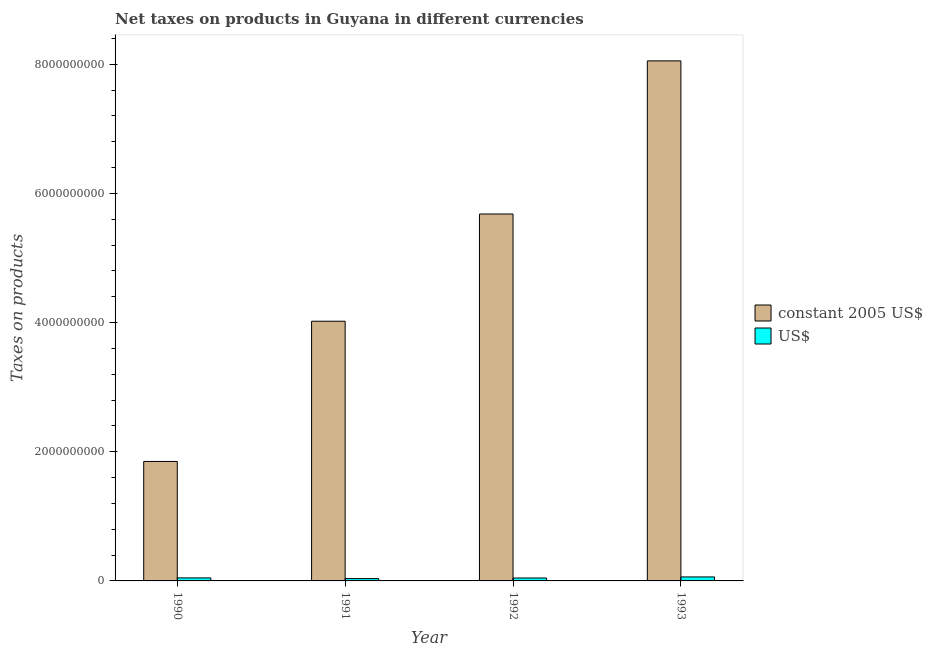How many groups of bars are there?
Your answer should be very brief. 4. Are the number of bars per tick equal to the number of legend labels?
Give a very brief answer. Yes. Are the number of bars on each tick of the X-axis equal?
Ensure brevity in your answer.  Yes. How many bars are there on the 1st tick from the left?
Your answer should be compact. 2. How many bars are there on the 4th tick from the right?
Provide a short and direct response. 2. What is the label of the 2nd group of bars from the left?
Keep it short and to the point. 1991. In how many cases, is the number of bars for a given year not equal to the number of legend labels?
Provide a succinct answer. 0. What is the net taxes in us$ in 1993?
Your answer should be compact. 6.18e+07. Across all years, what is the maximum net taxes in constant 2005 us$?
Your answer should be compact. 8.05e+09. Across all years, what is the minimum net taxes in constant 2005 us$?
Your answer should be very brief. 1.85e+09. In which year was the net taxes in constant 2005 us$ maximum?
Ensure brevity in your answer.  1993. In which year was the net taxes in us$ minimum?
Provide a short and direct response. 1991. What is the total net taxes in constant 2005 us$ in the graph?
Your answer should be compact. 1.96e+1. What is the difference between the net taxes in us$ in 1992 and that in 1993?
Your answer should be compact. -1.64e+07. What is the difference between the net taxes in us$ in 1991 and the net taxes in constant 2005 us$ in 1992?
Provide a succinct answer. -9.45e+06. What is the average net taxes in us$ per year?
Ensure brevity in your answer.  4.75e+07. In how many years, is the net taxes in constant 2005 us$ greater than 5600000000 units?
Your answer should be very brief. 2. What is the ratio of the net taxes in us$ in 1990 to that in 1992?
Offer a very short reply. 1.03. Is the net taxes in us$ in 1992 less than that in 1993?
Your response must be concise. Yes. What is the difference between the highest and the second highest net taxes in us$?
Provide a short and direct response. 1.50e+07. What is the difference between the highest and the lowest net taxes in constant 2005 us$?
Provide a short and direct response. 6.20e+09. In how many years, is the net taxes in constant 2005 us$ greater than the average net taxes in constant 2005 us$ taken over all years?
Ensure brevity in your answer.  2. What does the 1st bar from the left in 1990 represents?
Provide a succinct answer. Constant 2005 us$. What does the 2nd bar from the right in 1991 represents?
Keep it short and to the point. Constant 2005 us$. Are all the bars in the graph horizontal?
Make the answer very short. No. How many years are there in the graph?
Provide a short and direct response. 4. Does the graph contain any zero values?
Keep it short and to the point. No. Does the graph contain grids?
Your answer should be very brief. No. Where does the legend appear in the graph?
Provide a short and direct response. Center right. How many legend labels are there?
Give a very brief answer. 2. What is the title of the graph?
Provide a short and direct response. Net taxes on products in Guyana in different currencies. What is the label or title of the Y-axis?
Keep it short and to the point. Taxes on products. What is the Taxes on products in constant 2005 US$ in 1990?
Your answer should be compact. 1.85e+09. What is the Taxes on products in US$ in 1990?
Your answer should be very brief. 4.68e+07. What is the Taxes on products in constant 2005 US$ in 1991?
Offer a very short reply. 4.02e+09. What is the Taxes on products of US$ in 1991?
Ensure brevity in your answer.  3.60e+07. What is the Taxes on products in constant 2005 US$ in 1992?
Ensure brevity in your answer.  5.68e+09. What is the Taxes on products of US$ in 1992?
Provide a short and direct response. 4.54e+07. What is the Taxes on products of constant 2005 US$ in 1993?
Offer a terse response. 8.05e+09. What is the Taxes on products in US$ in 1993?
Keep it short and to the point. 6.18e+07. Across all years, what is the maximum Taxes on products of constant 2005 US$?
Offer a terse response. 8.05e+09. Across all years, what is the maximum Taxes on products in US$?
Provide a short and direct response. 6.18e+07. Across all years, what is the minimum Taxes on products in constant 2005 US$?
Your answer should be very brief. 1.85e+09. Across all years, what is the minimum Taxes on products in US$?
Your response must be concise. 3.60e+07. What is the total Taxes on products in constant 2005 US$ in the graph?
Make the answer very short. 1.96e+1. What is the total Taxes on products of US$ in the graph?
Your answer should be compact. 1.90e+08. What is the difference between the Taxes on products of constant 2005 US$ in 1990 and that in 1991?
Provide a short and direct response. -2.17e+09. What is the difference between the Taxes on products of US$ in 1990 and that in 1991?
Your answer should be very brief. 1.09e+07. What is the difference between the Taxes on products in constant 2005 US$ in 1990 and that in 1992?
Offer a very short reply. -3.83e+09. What is the difference between the Taxes on products in US$ in 1990 and that in 1992?
Your answer should be compact. 1.42e+06. What is the difference between the Taxes on products of constant 2005 US$ in 1990 and that in 1993?
Ensure brevity in your answer.  -6.20e+09. What is the difference between the Taxes on products in US$ in 1990 and that in 1993?
Ensure brevity in your answer.  -1.50e+07. What is the difference between the Taxes on products in constant 2005 US$ in 1991 and that in 1992?
Offer a terse response. -1.66e+09. What is the difference between the Taxes on products of US$ in 1991 and that in 1992?
Keep it short and to the point. -9.45e+06. What is the difference between the Taxes on products of constant 2005 US$ in 1991 and that in 1993?
Offer a very short reply. -4.03e+09. What is the difference between the Taxes on products in US$ in 1991 and that in 1993?
Offer a very short reply. -2.59e+07. What is the difference between the Taxes on products in constant 2005 US$ in 1992 and that in 1993?
Offer a very short reply. -2.37e+09. What is the difference between the Taxes on products of US$ in 1992 and that in 1993?
Offer a terse response. -1.64e+07. What is the difference between the Taxes on products in constant 2005 US$ in 1990 and the Taxes on products in US$ in 1991?
Your answer should be very brief. 1.81e+09. What is the difference between the Taxes on products of constant 2005 US$ in 1990 and the Taxes on products of US$ in 1992?
Your response must be concise. 1.80e+09. What is the difference between the Taxes on products in constant 2005 US$ in 1990 and the Taxes on products in US$ in 1993?
Provide a short and direct response. 1.79e+09. What is the difference between the Taxes on products in constant 2005 US$ in 1991 and the Taxes on products in US$ in 1992?
Make the answer very short. 3.98e+09. What is the difference between the Taxes on products of constant 2005 US$ in 1991 and the Taxes on products of US$ in 1993?
Provide a succinct answer. 3.96e+09. What is the difference between the Taxes on products of constant 2005 US$ in 1992 and the Taxes on products of US$ in 1993?
Offer a terse response. 5.62e+09. What is the average Taxes on products of constant 2005 US$ per year?
Provide a short and direct response. 4.90e+09. What is the average Taxes on products in US$ per year?
Offer a terse response. 4.75e+07. In the year 1990, what is the difference between the Taxes on products of constant 2005 US$ and Taxes on products of US$?
Your answer should be very brief. 1.80e+09. In the year 1991, what is the difference between the Taxes on products in constant 2005 US$ and Taxes on products in US$?
Provide a short and direct response. 3.99e+09. In the year 1992, what is the difference between the Taxes on products in constant 2005 US$ and Taxes on products in US$?
Your answer should be very brief. 5.64e+09. In the year 1993, what is the difference between the Taxes on products in constant 2005 US$ and Taxes on products in US$?
Your response must be concise. 7.99e+09. What is the ratio of the Taxes on products in constant 2005 US$ in 1990 to that in 1991?
Ensure brevity in your answer.  0.46. What is the ratio of the Taxes on products of US$ in 1990 to that in 1991?
Offer a very short reply. 1.3. What is the ratio of the Taxes on products of constant 2005 US$ in 1990 to that in 1992?
Your answer should be compact. 0.33. What is the ratio of the Taxes on products in US$ in 1990 to that in 1992?
Give a very brief answer. 1.03. What is the ratio of the Taxes on products in constant 2005 US$ in 1990 to that in 1993?
Make the answer very short. 0.23. What is the ratio of the Taxes on products of US$ in 1990 to that in 1993?
Offer a terse response. 0.76. What is the ratio of the Taxes on products of constant 2005 US$ in 1991 to that in 1992?
Provide a short and direct response. 0.71. What is the ratio of the Taxes on products of US$ in 1991 to that in 1992?
Keep it short and to the point. 0.79. What is the ratio of the Taxes on products of constant 2005 US$ in 1991 to that in 1993?
Offer a terse response. 0.5. What is the ratio of the Taxes on products in US$ in 1991 to that in 1993?
Keep it short and to the point. 0.58. What is the ratio of the Taxes on products of constant 2005 US$ in 1992 to that in 1993?
Give a very brief answer. 0.71. What is the ratio of the Taxes on products in US$ in 1992 to that in 1993?
Your answer should be compact. 0.73. What is the difference between the highest and the second highest Taxes on products in constant 2005 US$?
Provide a succinct answer. 2.37e+09. What is the difference between the highest and the second highest Taxes on products of US$?
Your response must be concise. 1.50e+07. What is the difference between the highest and the lowest Taxes on products in constant 2005 US$?
Your answer should be very brief. 6.20e+09. What is the difference between the highest and the lowest Taxes on products of US$?
Make the answer very short. 2.59e+07. 